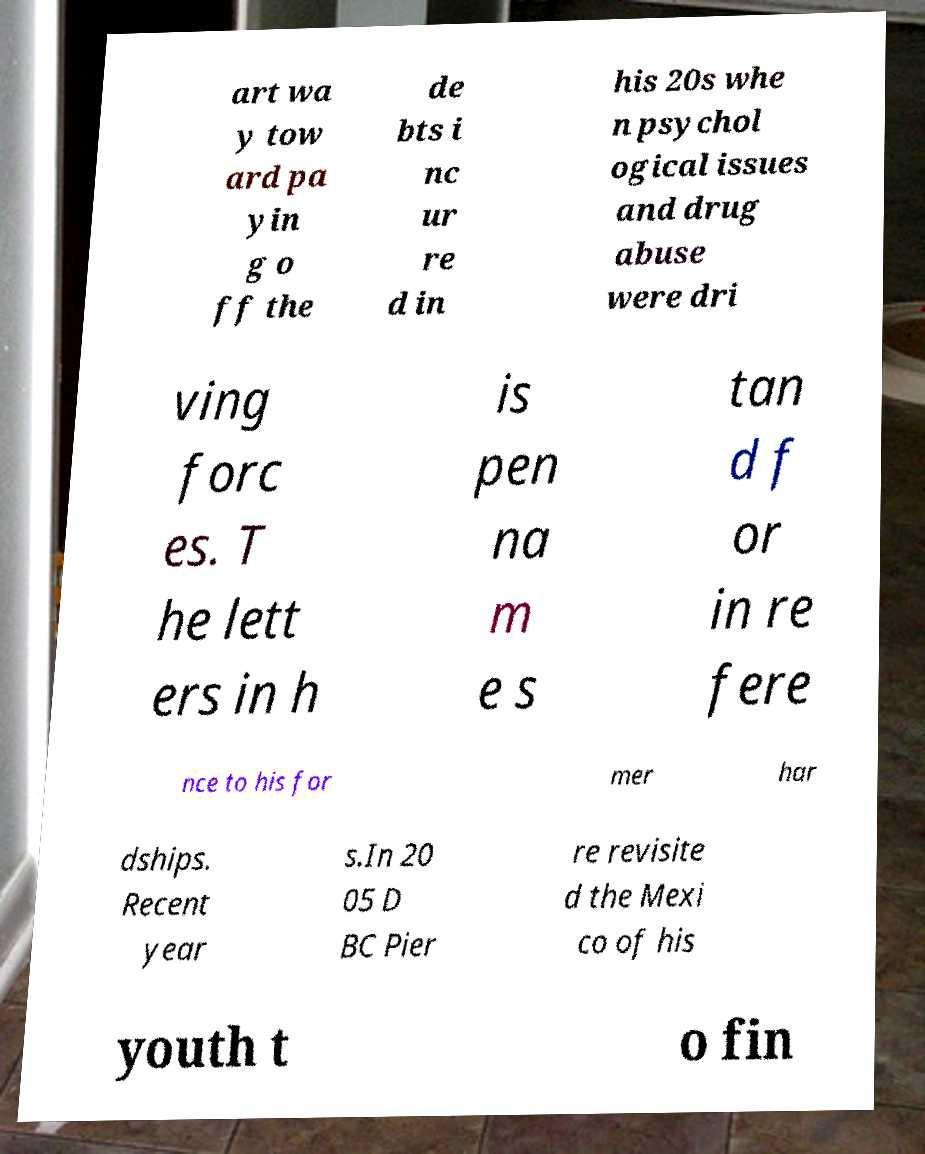There's text embedded in this image that I need extracted. Can you transcribe it verbatim? art wa y tow ard pa yin g o ff the de bts i nc ur re d in his 20s whe n psychol ogical issues and drug abuse were dri ving forc es. T he lett ers in h is pen na m e s tan d f or in re fere nce to his for mer har dships. Recent year s.In 20 05 D BC Pier re revisite d the Mexi co of his youth t o fin 